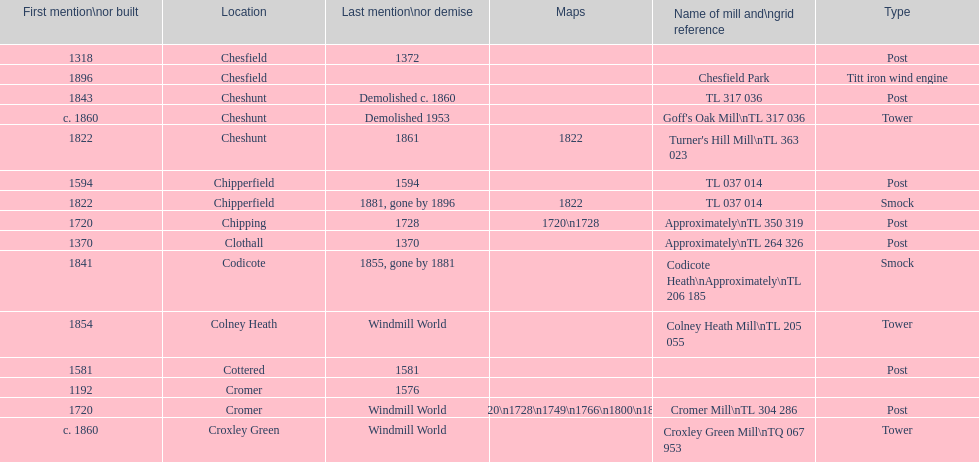How many mills were mentioned or built before 1700? 5. 